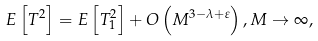Convert formula to latex. <formula><loc_0><loc_0><loc_500><loc_500>E \left [ T ^ { 2 } \right ] = E \left [ T _ { 1 } ^ { 2 } \right ] + O \left ( M ^ { 3 - \lambda + \varepsilon } \right ) , M \to \infty ,</formula> 